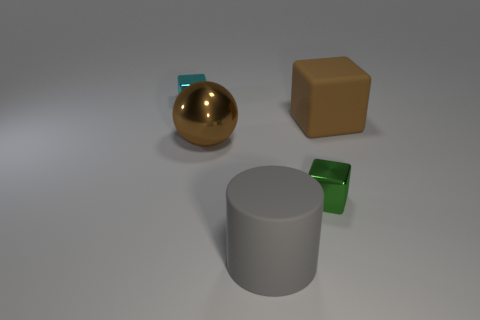Are there any yellow objects that have the same size as the rubber cube?
Ensure brevity in your answer.  No. Does the shiny object that is right of the big cylinder have the same color as the tiny thing that is behind the large metal ball?
Offer a very short reply. No. How many metallic things are either large cylinders or large brown cubes?
Offer a very short reply. 0. There is a big brown cube that is in front of the thing behind the brown block; how many large balls are on the left side of it?
Offer a terse response. 1. What is the size of the cyan thing that is made of the same material as the brown ball?
Your answer should be very brief. Small. What number of big matte cubes are the same color as the big ball?
Ensure brevity in your answer.  1. There is a metallic cube that is left of the green metal thing; is its size the same as the large gray rubber thing?
Ensure brevity in your answer.  No. What is the color of the big thing that is to the left of the large brown block and behind the gray thing?
Offer a terse response. Brown. How many objects are either big cyan shiny cylinders or cyan cubes that are behind the big gray matte thing?
Your response must be concise. 1. The tiny thing to the right of the cyan metallic thing behind the small green metal object behind the big cylinder is made of what material?
Provide a short and direct response. Metal. 